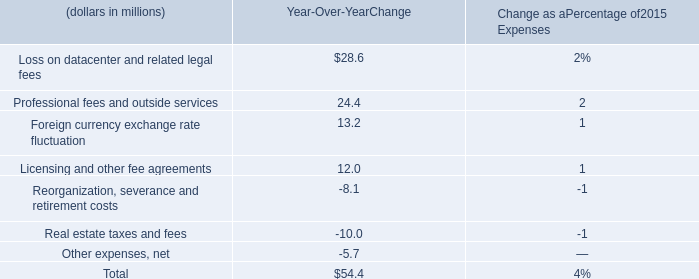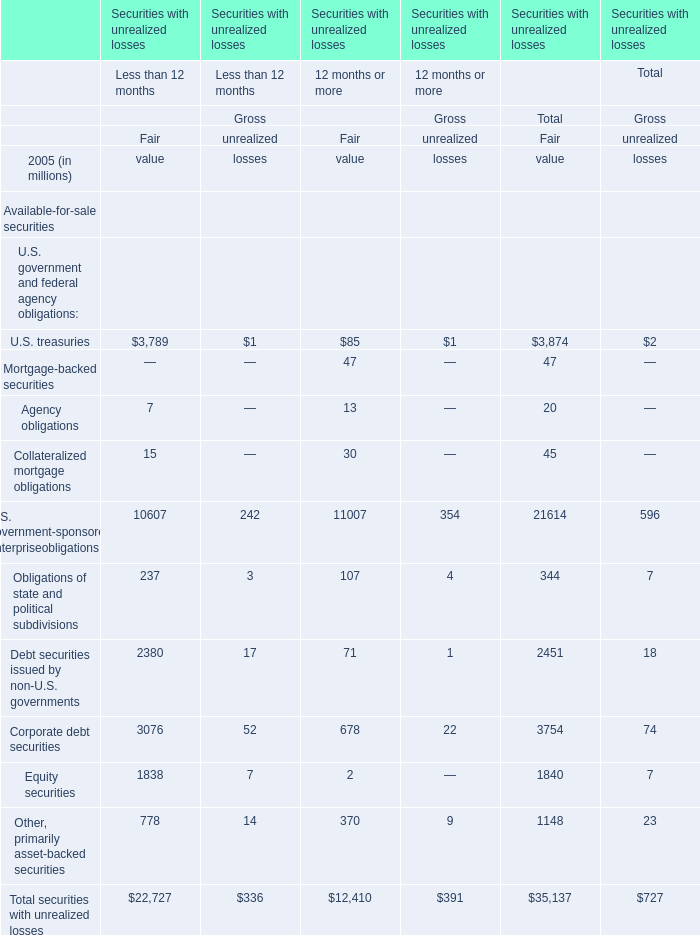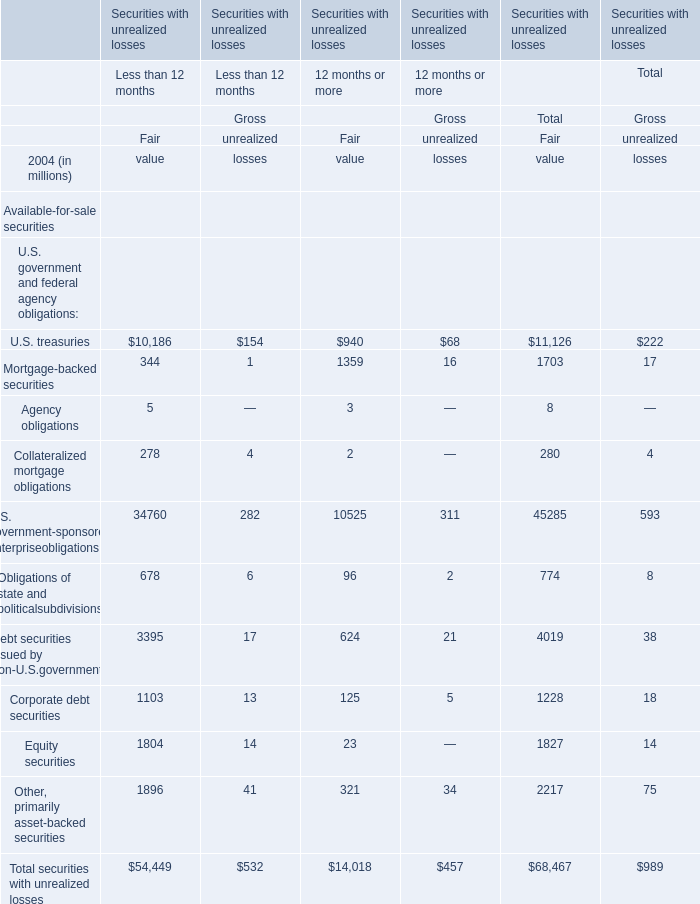Is the total amount of all elements in Fair value of 12 months or more greater than that in Fair value of Less than 12 months? 
Answer: No. 